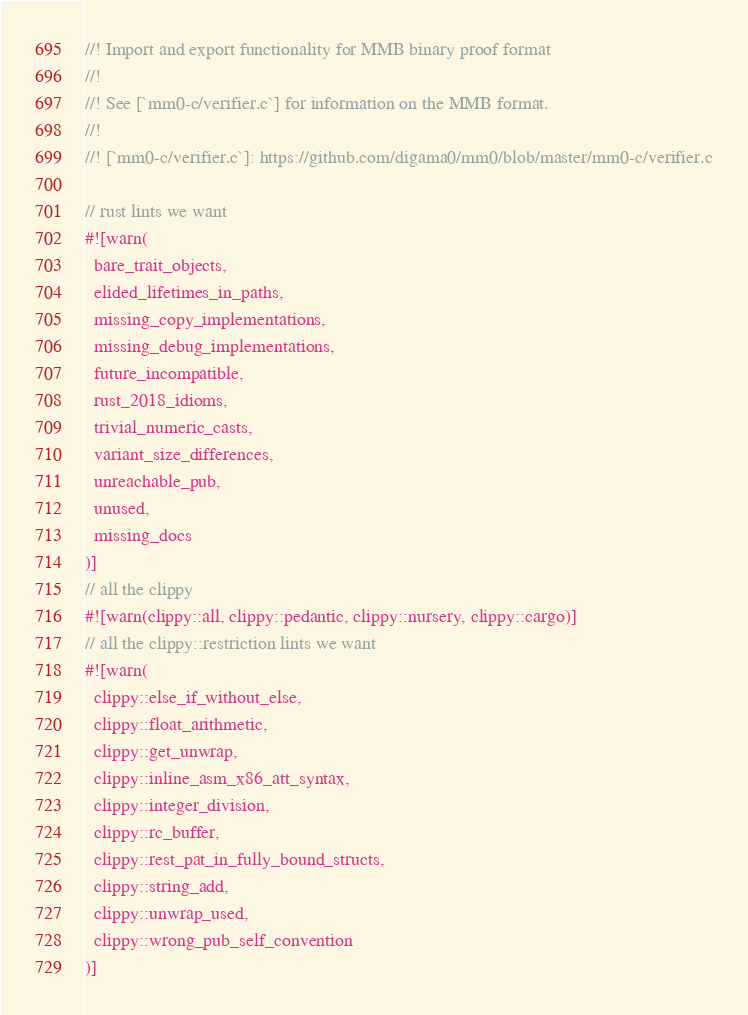<code> <loc_0><loc_0><loc_500><loc_500><_Rust_>//! Import and export functionality for MMB binary proof format
//!
//! See [`mm0-c/verifier.c`] for information on the MMB format.
//!
//! [`mm0-c/verifier.c`]: https://github.com/digama0/mm0/blob/master/mm0-c/verifier.c

// rust lints we want
#![warn(
  bare_trait_objects,
  elided_lifetimes_in_paths,
  missing_copy_implementations,
  missing_debug_implementations,
  future_incompatible,
  rust_2018_idioms,
  trivial_numeric_casts,
  variant_size_differences,
  unreachable_pub,
  unused,
  missing_docs
)]
// all the clippy
#![warn(clippy::all, clippy::pedantic, clippy::nursery, clippy::cargo)]
// all the clippy::restriction lints we want
#![warn(
  clippy::else_if_without_else,
  clippy::float_arithmetic,
  clippy::get_unwrap,
  clippy::inline_asm_x86_att_syntax,
  clippy::integer_division,
  clippy::rc_buffer,
  clippy::rest_pat_in_fully_bound_structs,
  clippy::string_add,
  clippy::unwrap_used,
  clippy::wrong_pub_self_convention
)]</code> 